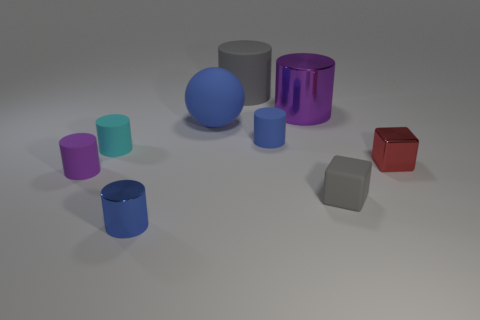How many blue cylinders must be subtracted to get 1 blue cylinders? 1 Subtract all gray cylinders. How many cylinders are left? 5 Subtract 1 cylinders. How many cylinders are left? 5 Subtract all cyan cylinders. How many cylinders are left? 5 Add 1 tiny cyan rubber things. How many objects exist? 10 Subtract all blue cylinders. Subtract all green cubes. How many cylinders are left? 4 Subtract all cylinders. How many objects are left? 3 Subtract 0 yellow blocks. How many objects are left? 9 Subtract all blue cylinders. Subtract all big blue objects. How many objects are left? 6 Add 5 tiny blue metal cylinders. How many tiny blue metal cylinders are left? 6 